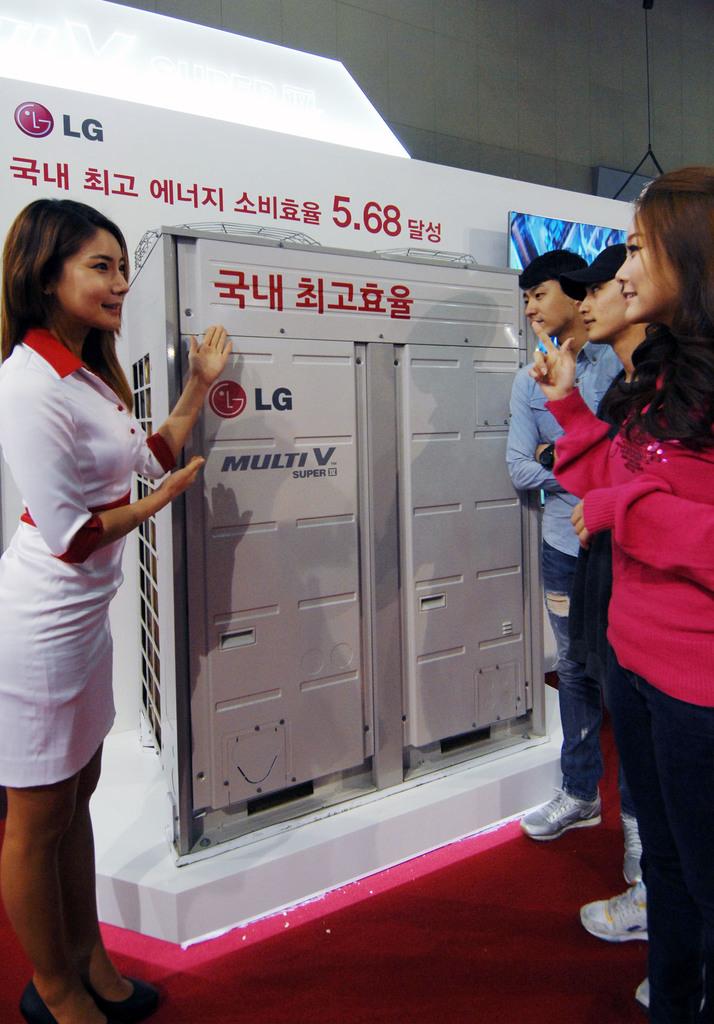What company is this for?
Ensure brevity in your answer.  Lg. 